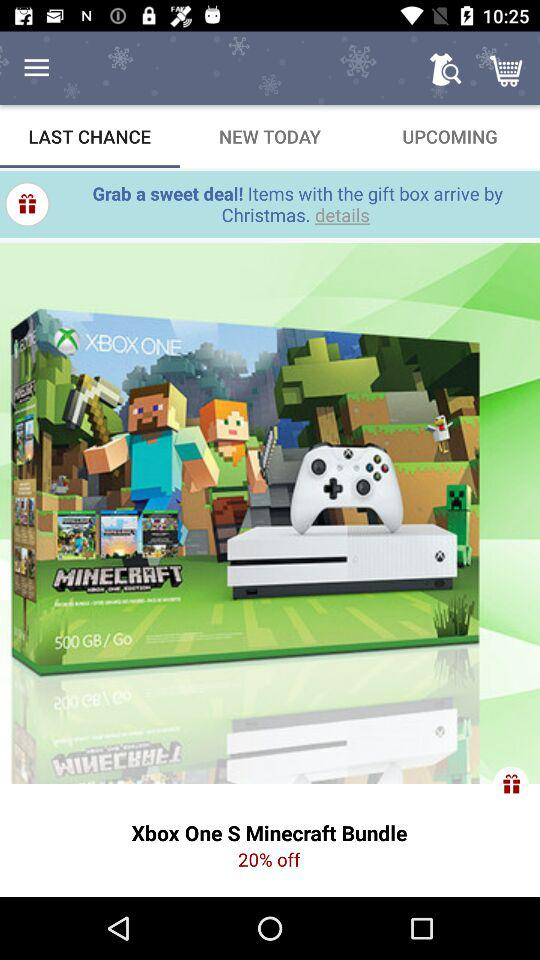How much is the Xbox One S Minecraft Bundle discounted by?
Answer the question using a single word or phrase. 20% 